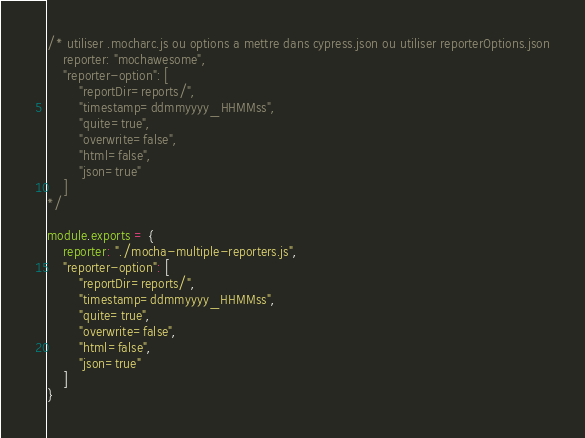Convert code to text. <code><loc_0><loc_0><loc_500><loc_500><_JavaScript_>/* utiliser .mocharc.js ou options a mettre dans cypress.json ou utiliser reporterOptions.json
    reporter: "mochawesome",
    "reporter-option": [
        "reportDir=reports/",
        "timestamp=ddmmyyyy_HHMMss",
        "quite=true",
        "overwrite=false",
        "html=false",
        "json=true"
    ]
*/

module.exports = {
    reporter: "./mocha-multiple-reporters.js",
    "reporter-option": [
        "reportDir=reports/",
        "timestamp=ddmmyyyy_HHMMss",
        "quite=true",
        "overwrite=false",
        "html=false",
        "json=true"
    ]
}</code> 